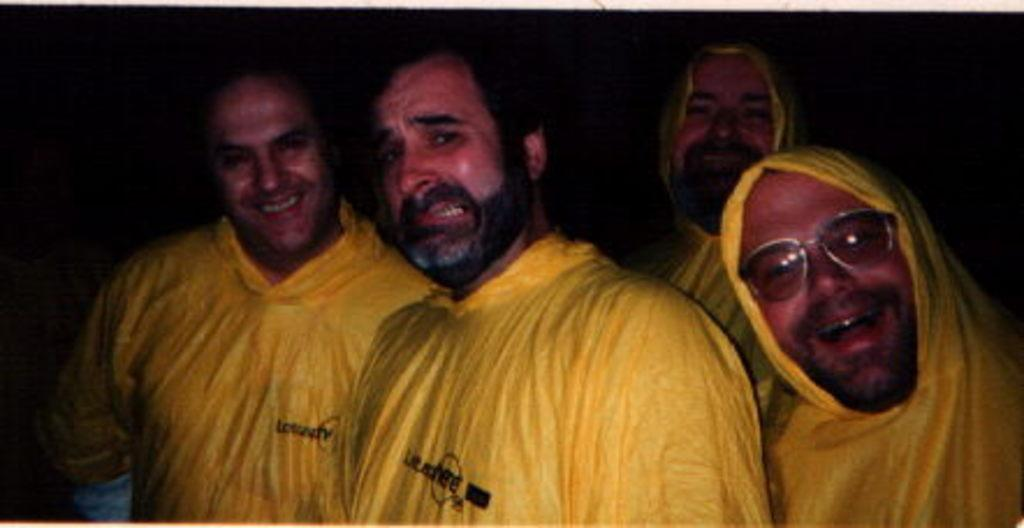How many people are in the image? There are people in the image, but the exact number is not specified. Can you describe any specific features of one of the people? Yes, one person is wearing glasses. What can be observed about the background of the image? The background of the image is dark. What type of tree can be seen in the background of the image? There is no tree visible in the background of the image; it is described as being dark. Can you describe the lip color of the person wearing glasses? The facts provided do not mention any information about the lip color of the person wearing glasses. 